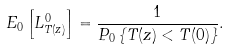Convert formula to latex. <formula><loc_0><loc_0><loc_500><loc_500>E _ { 0 } \left [ L ^ { 0 } _ { T ( z ) } \right ] = \frac { 1 } { P _ { 0 } \left \{ T ( z ) < T ( 0 ) \right \} } .</formula> 